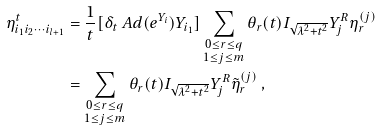<formula> <loc_0><loc_0><loc_500><loc_500>\eta ^ { t } _ { i _ { 1 } i _ { 2 } \cdots i _ { l + 1 } } & = \frac { 1 } { t } [ \delta _ { t } \ A d ( { e ^ { Y _ { i } } } ) Y _ { i _ { 1 } } ] \sum _ { \substack { 0 \leq r \leq q \\ 1 \leq j \leq m } } \theta _ { r } ( t ) I _ { \sqrt { \lambda ^ { 2 } + t ^ { 2 } } } Y _ { j } ^ { R } \eta ^ { ( j ) } _ { r } \\ & = \sum _ { \substack { 0 \leq r \leq q \\ 1 \leq j \leq m } } \theta _ { r } ( t ) I _ { \sqrt { \lambda ^ { 2 } + t ^ { 2 } } } Y _ { j } ^ { R } \tilde { \eta } ^ { ( j ) } _ { r } \, ,</formula> 